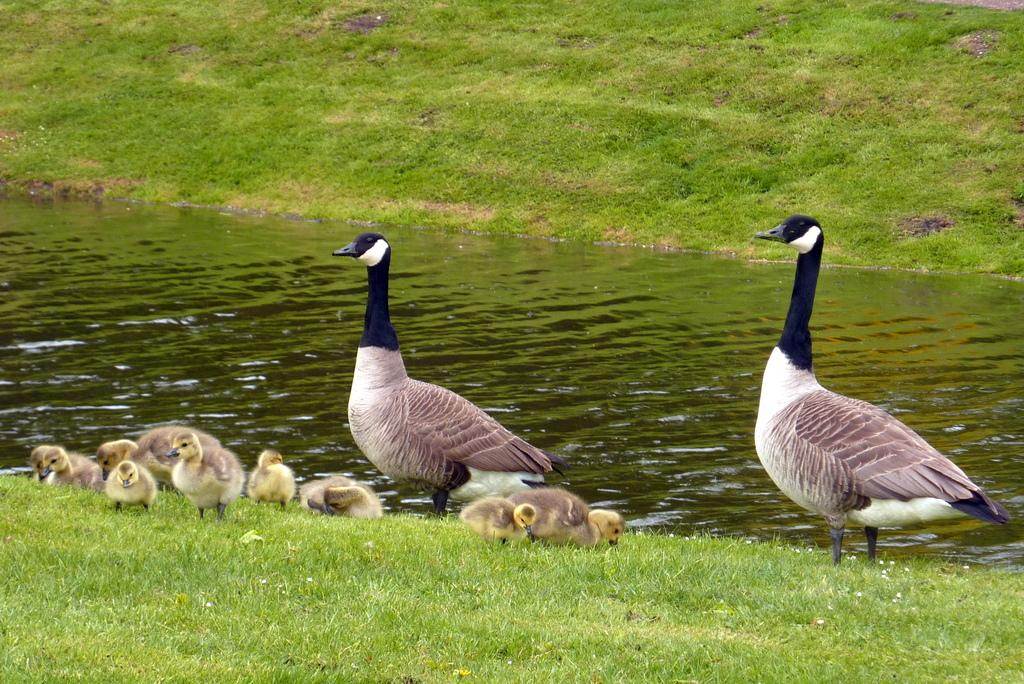What type of vegetation is present on both sides of the image? There is grass on both sides of the image. What is located in the middle of the image? There is water in the middle of the image. Are there any animals visible in the image? Yes, there are birds on the grass. What type of cable can be seen connecting the birds in the image? There is no cable present in the image; the birds are on the grass and not connected by any cable. What action do the birds take to start flying in the image? The image does not show the birds taking any action to start flying; they are already on the grass. 